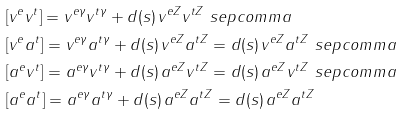Convert formula to latex. <formula><loc_0><loc_0><loc_500><loc_500>& [ v ^ { e } v ^ { t } ] = v ^ { e \gamma } v ^ { t \gamma } + d ( s ) \, v ^ { e Z } v ^ { t Z } \ s e p c o m m a \\ & [ v ^ { e } a ^ { t } ] = v ^ { e \gamma } a ^ { t \gamma } + d ( s ) \, v ^ { e Z } a ^ { t Z } = d ( s ) \, v ^ { e Z } a ^ { t Z } \ s e p c o m m a \\ & [ a ^ { e } v ^ { t } ] = a ^ { e \gamma } v ^ { t \gamma } + d ( s ) \, a ^ { e Z } v ^ { t Z } = d ( s ) \, a ^ { e Z } v ^ { t Z } \ s e p c o m m a \\ & [ a ^ { e } a ^ { t } ] = a ^ { e \gamma } a ^ { t \gamma } + d ( s ) \, a ^ { e Z } a ^ { t Z } = d ( s ) \, a ^ { e Z } a ^ { t Z }</formula> 